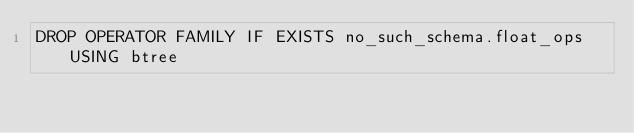<code> <loc_0><loc_0><loc_500><loc_500><_SQL_>DROP OPERATOR FAMILY IF EXISTS no_such_schema.float_ops USING btree
</code> 